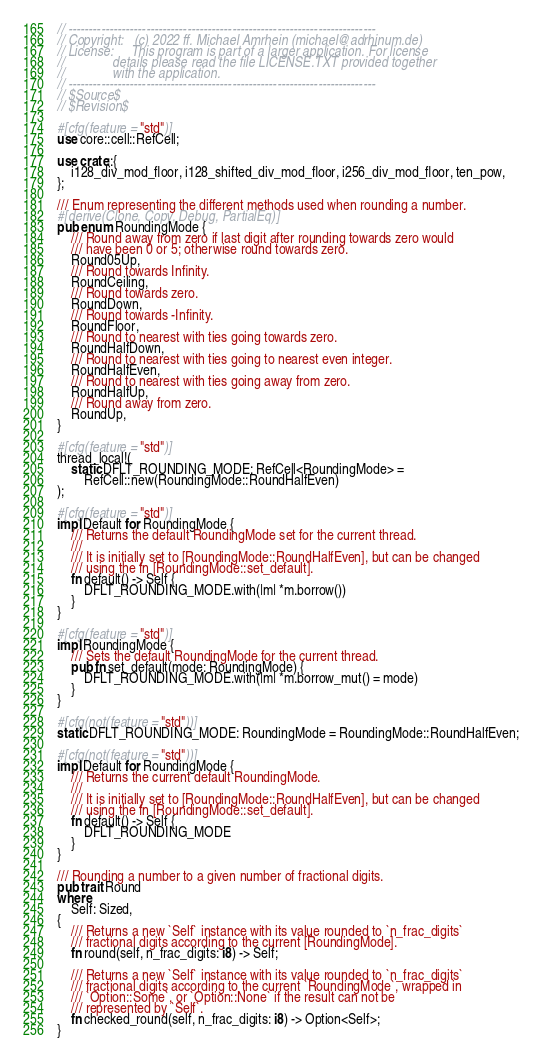Convert code to text. <code><loc_0><loc_0><loc_500><loc_500><_Rust_>// ---------------------------------------------------------------------------
// Copyright:   (c) 2022 ff. Michael Amrhein (michael@adrhinum.de)
// License:     This program is part of a larger application. For license
//              details please read the file LICENSE.TXT provided together
//              with the application.
// ---------------------------------------------------------------------------
// $Source$
// $Revision$

#[cfg(feature = "std")]
use core::cell::RefCell;

use crate::{
    i128_div_mod_floor, i128_shifted_div_mod_floor, i256_div_mod_floor, ten_pow,
};

/// Enum representing the different methods used when rounding a number.
#[derive(Clone, Copy, Debug, PartialEq)]
pub enum RoundingMode {
    /// Round away from zero if last digit after rounding towards zero would
    /// have been 0 or 5; otherwise round towards zero.
    Round05Up,
    /// Round towards Infinity.
    RoundCeiling,
    /// Round towards zero.
    RoundDown,
    /// Round towards -Infinity.
    RoundFloor,
    /// Round to nearest with ties going towards zero.
    RoundHalfDown,
    /// Round to nearest with ties going to nearest even integer.
    RoundHalfEven,
    /// Round to nearest with ties going away from zero.
    RoundHalfUp,
    /// Round away from zero.
    RoundUp,
}

#[cfg(feature = "std")]
thread_local!(
    static DFLT_ROUNDING_MODE: RefCell<RoundingMode> =
        RefCell::new(RoundingMode::RoundHalfEven)
);

#[cfg(feature = "std")]
impl Default for RoundingMode {
    /// Returns the default RoundingMode set for the current thread.
    ///
    /// It is initially set to [RoundingMode::RoundHalfEven], but can be changed
    /// using the fn [RoundingMode::set_default].
    fn default() -> Self {
        DFLT_ROUNDING_MODE.with(|m| *m.borrow())
    }
}

#[cfg(feature = "std")]
impl RoundingMode {
    /// Sets the default RoundingMode for the current thread.
    pub fn set_default(mode: RoundingMode) {
        DFLT_ROUNDING_MODE.with(|m| *m.borrow_mut() = mode)
    }
}

#[cfg(not(feature = "std"))]
static DFLT_ROUNDING_MODE: RoundingMode = RoundingMode::RoundHalfEven;

#[cfg(not(feature = "std"))]
impl Default for RoundingMode {
    /// Returns the current default RoundingMode.
    ///
    /// It is initially set to [RoundingMode::RoundHalfEven], but can be changed
    /// using the fn [RoundingMode::set_default].
    fn default() -> Self {
        DFLT_ROUNDING_MODE
    }
}

/// Rounding a number to a given number of fractional digits.
pub trait Round
where
    Self: Sized,
{
    /// Returns a new `Self` instance with its value rounded to `n_frac_digits`
    /// fractional digits according to the current [RoundingMode].
    fn round(self, n_frac_digits: i8) -> Self;

    /// Returns a new `Self` instance with its value rounded to `n_frac_digits`
    /// fractional digits according to the current `RoundingMode`, wrapped in
    /// `Option::Some`, or `Option::None` if the result can not be
    /// represented by `Self`.
    fn checked_round(self, n_frac_digits: i8) -> Option<Self>;
}
</code> 